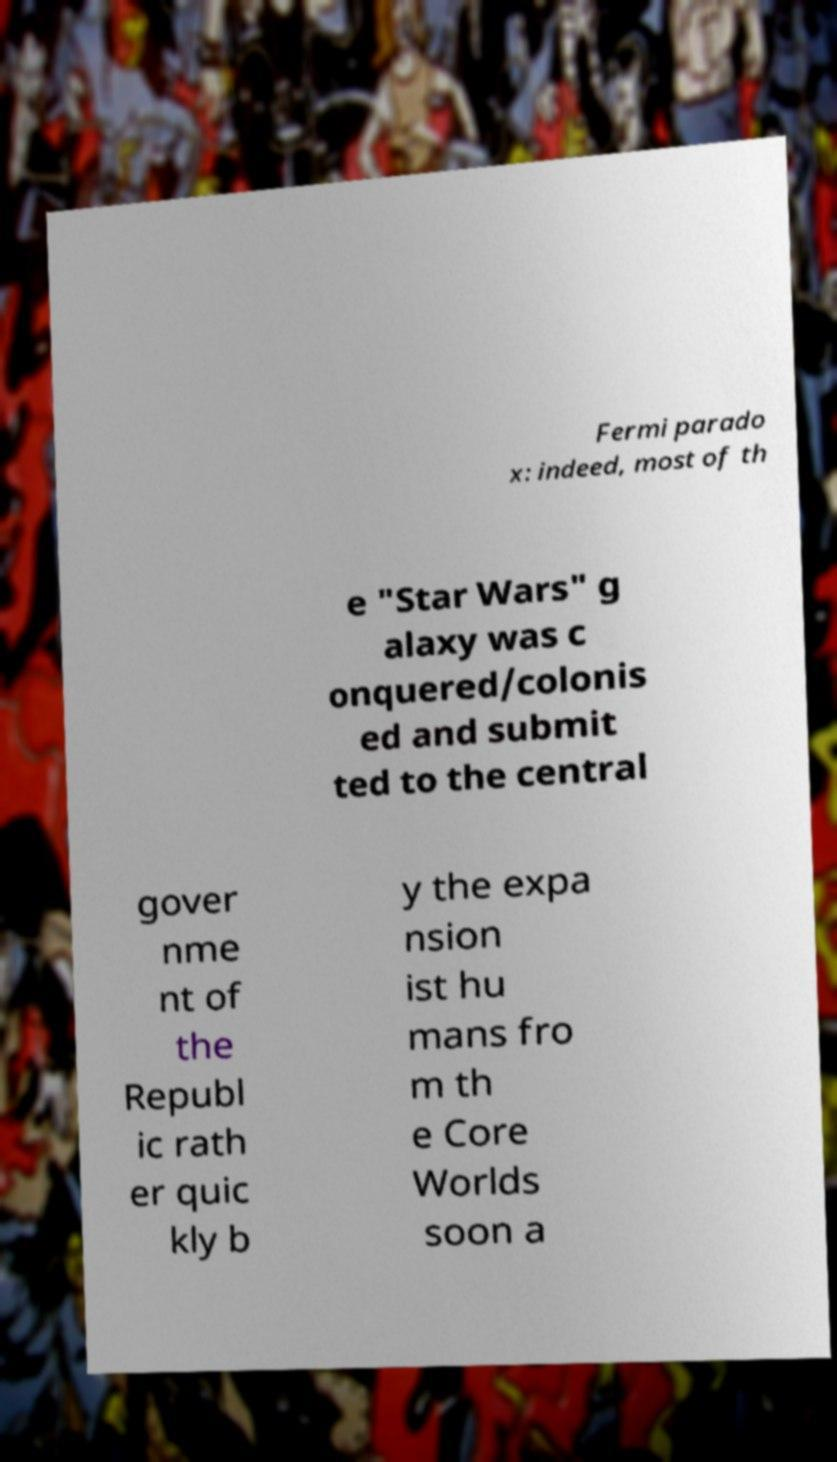Please read and relay the text visible in this image. What does it say? Fermi parado x: indeed, most of th e "Star Wars" g alaxy was c onquered/colonis ed and submit ted to the central gover nme nt of the Republ ic rath er quic kly b y the expa nsion ist hu mans fro m th e Core Worlds soon a 